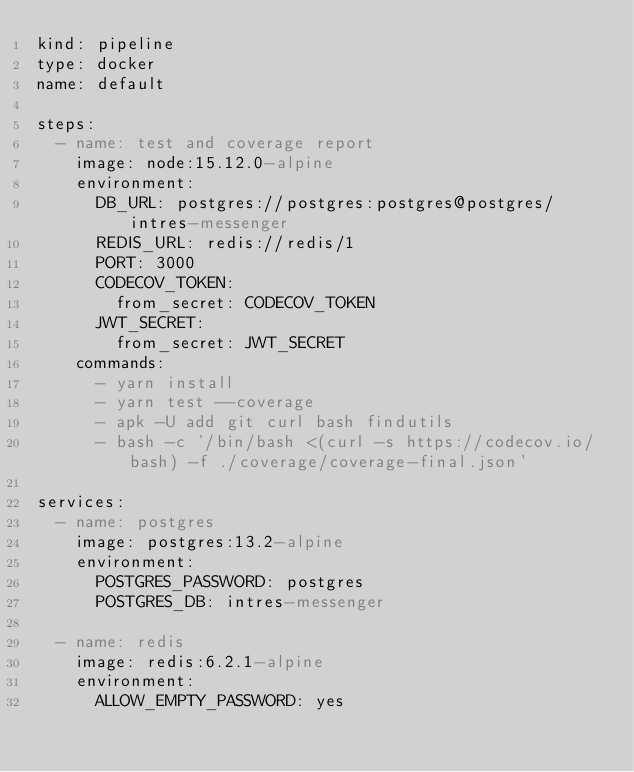Convert code to text. <code><loc_0><loc_0><loc_500><loc_500><_YAML_>kind: pipeline
type: docker
name: default

steps:
  - name: test and coverage report
    image: node:15.12.0-alpine
    environment:
      DB_URL: postgres://postgres:postgres@postgres/intres-messenger
      REDIS_URL: redis://redis/1
      PORT: 3000
      CODECOV_TOKEN:
        from_secret: CODECOV_TOKEN
      JWT_SECRET:
        from_secret: JWT_SECRET
    commands:
      - yarn install
      - yarn test --coverage
      - apk -U add git curl bash findutils
      - bash -c '/bin/bash <(curl -s https://codecov.io/bash) -f ./coverage/coverage-final.json'

services:
  - name: postgres
    image: postgres:13.2-alpine
    environment:
      POSTGRES_PASSWORD: postgres
      POSTGRES_DB: intres-messenger

  - name: redis
    image: redis:6.2.1-alpine
    environment:
      ALLOW_EMPTY_PASSWORD: yes
</code> 